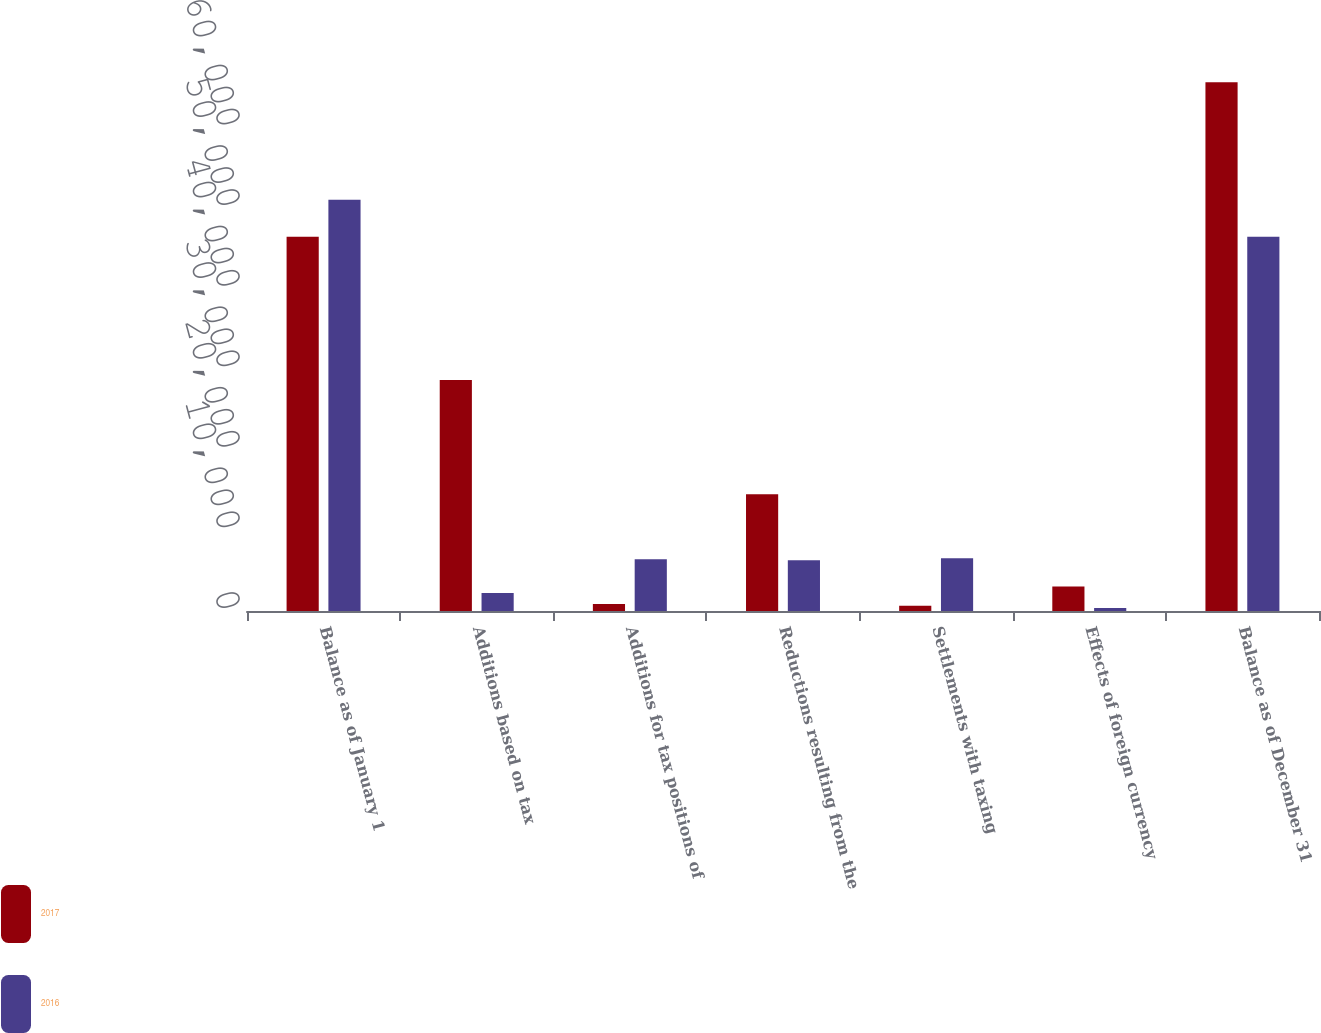Convert chart to OTSL. <chart><loc_0><loc_0><loc_500><loc_500><stacked_bar_chart><ecel><fcel>Balance as of January 1<fcel>Additions based on tax<fcel>Additions for tax positions of<fcel>Reductions resulting from the<fcel>Settlements with taxing<fcel>Effects of foreign currency<fcel>Balance as of December 31<nl><fcel>2017<fcel>46434<fcel>28663<fcel>876<fcel>14502<fcel>655<fcel>3039<fcel>65631<nl><fcel>2016<fcel>51037<fcel>2221<fcel>6412<fcel>6294<fcel>6555<fcel>387<fcel>46434<nl></chart> 